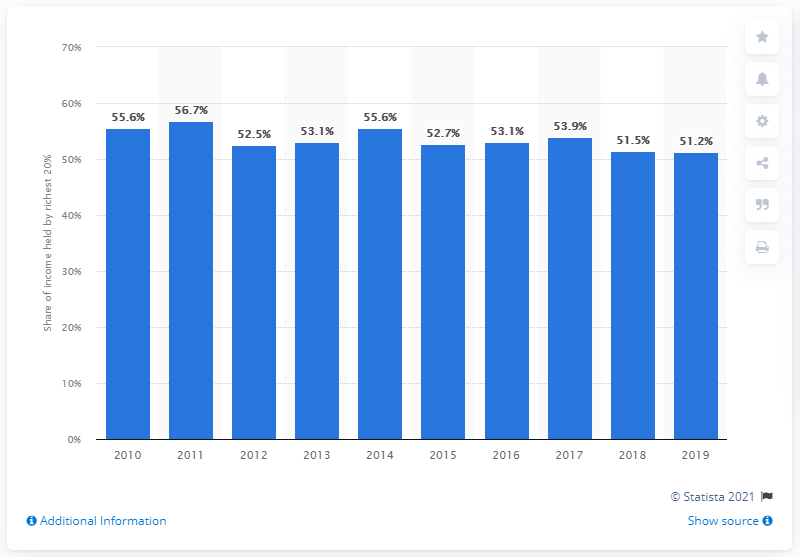List a handful of essential elements in this visual. Since 2017, Paraguay's wealth share has been decreasing. 